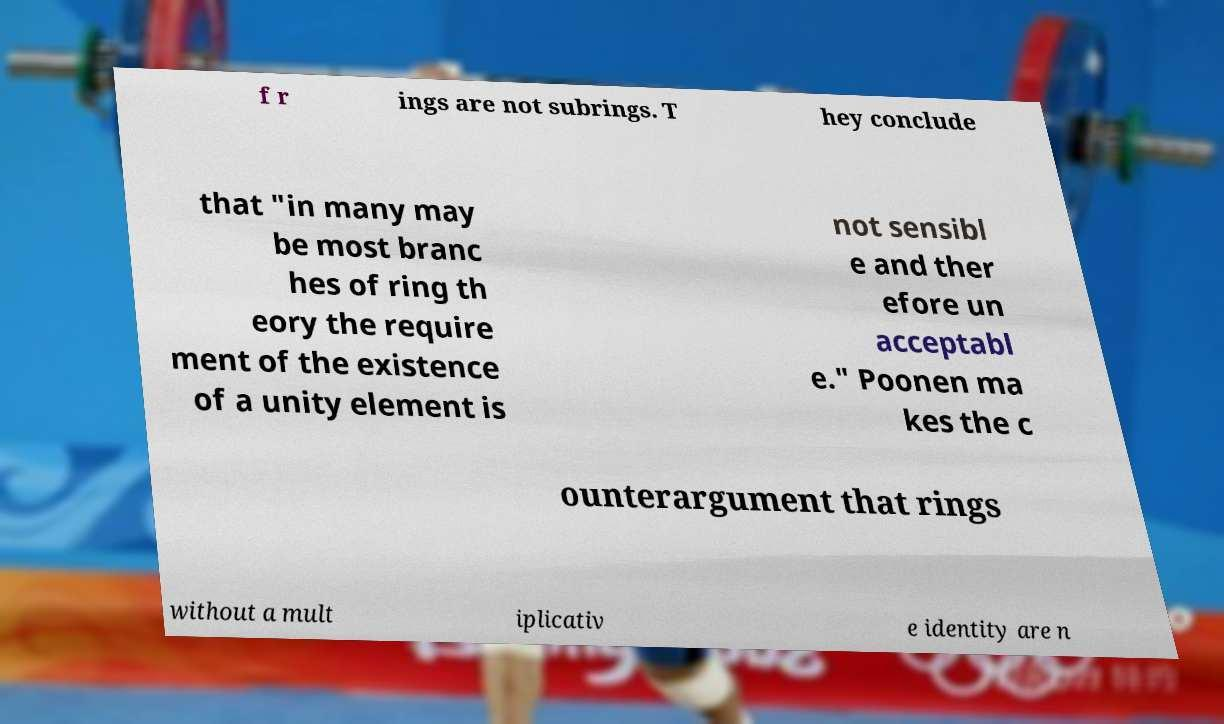Could you assist in decoding the text presented in this image and type it out clearly? f r ings are not subrings. T hey conclude that "in many may be most branc hes of ring th eory the require ment of the existence of a unity element is not sensibl e and ther efore un acceptabl e." Poonen ma kes the c ounterargument that rings without a mult iplicativ e identity are n 